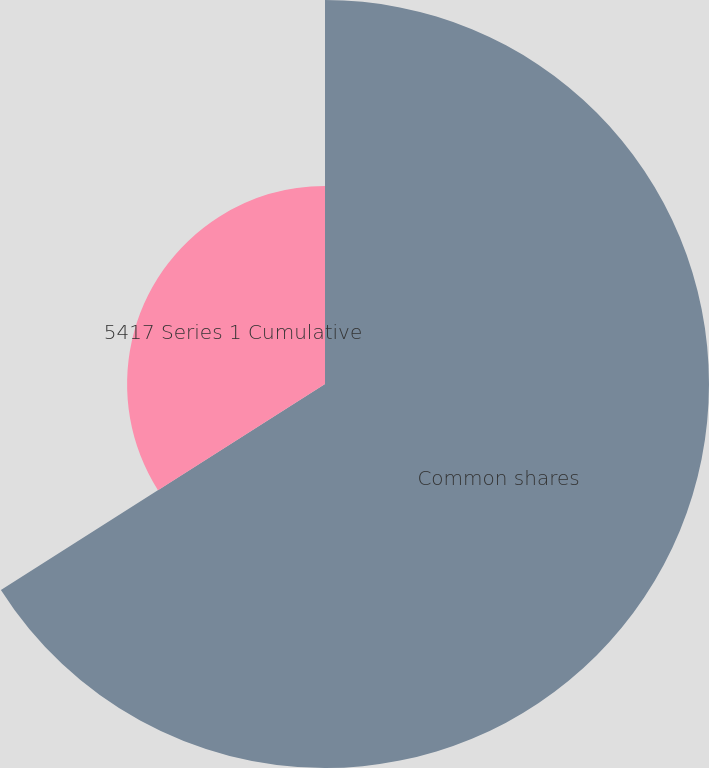Convert chart to OTSL. <chart><loc_0><loc_0><loc_500><loc_500><pie_chart><fcel>Common shares<fcel>5417 Series 1 Cumulative<nl><fcel>65.99%<fcel>34.01%<nl></chart> 